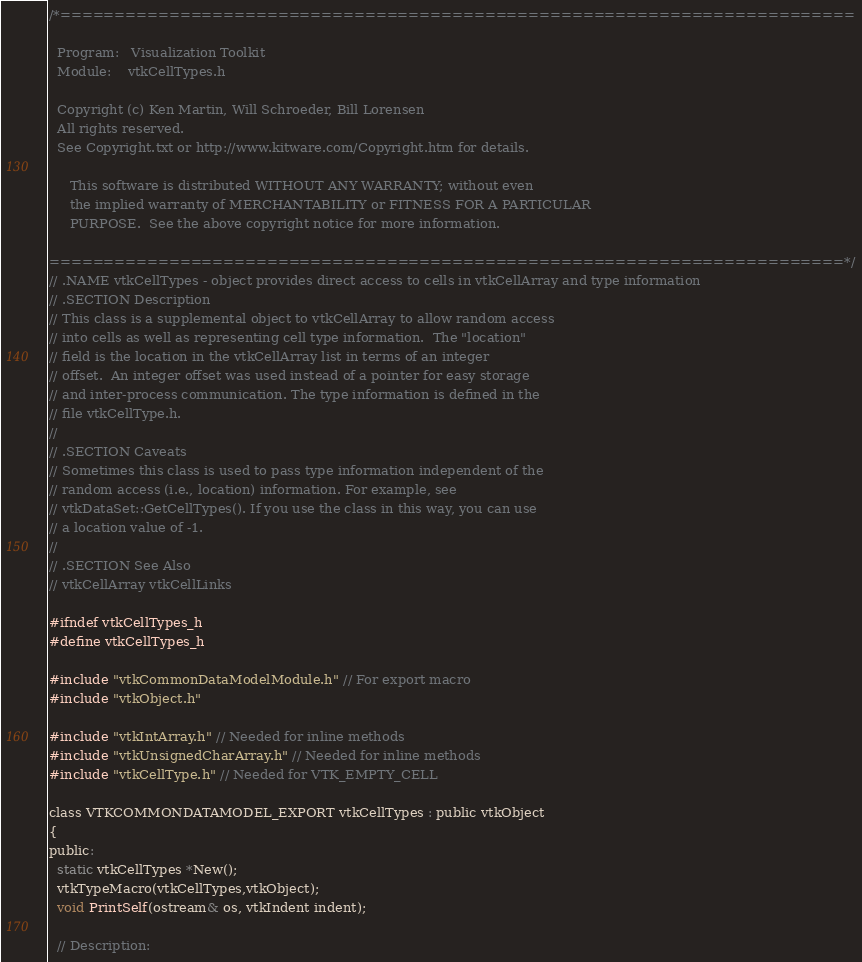<code> <loc_0><loc_0><loc_500><loc_500><_C_>/*=========================================================================

  Program:   Visualization Toolkit
  Module:    vtkCellTypes.h

  Copyright (c) Ken Martin, Will Schroeder, Bill Lorensen
  All rights reserved.
  See Copyright.txt or http://www.kitware.com/Copyright.htm for details.

     This software is distributed WITHOUT ANY WARRANTY; without even
     the implied warranty of MERCHANTABILITY or FITNESS FOR A PARTICULAR
     PURPOSE.  See the above copyright notice for more information.

=========================================================================*/
// .NAME vtkCellTypes - object provides direct access to cells in vtkCellArray and type information
// .SECTION Description
// This class is a supplemental object to vtkCellArray to allow random access
// into cells as well as representing cell type information.  The "location"
// field is the location in the vtkCellArray list in terms of an integer
// offset.  An integer offset was used instead of a pointer for easy storage
// and inter-process communication. The type information is defined in the
// file vtkCellType.h.
//
// .SECTION Caveats
// Sometimes this class is used to pass type information independent of the
// random access (i.e., location) information. For example, see
// vtkDataSet::GetCellTypes(). If you use the class in this way, you can use
// a location value of -1.
//
// .SECTION See Also
// vtkCellArray vtkCellLinks

#ifndef vtkCellTypes_h
#define vtkCellTypes_h

#include "vtkCommonDataModelModule.h" // For export macro
#include "vtkObject.h"

#include "vtkIntArray.h" // Needed for inline methods
#include "vtkUnsignedCharArray.h" // Needed for inline methods
#include "vtkCellType.h" // Needed for VTK_EMPTY_CELL

class VTKCOMMONDATAMODEL_EXPORT vtkCellTypes : public vtkObject
{
public:
  static vtkCellTypes *New();
  vtkTypeMacro(vtkCellTypes,vtkObject);
  void PrintSelf(ostream& os, vtkIndent indent);

  // Description:</code> 